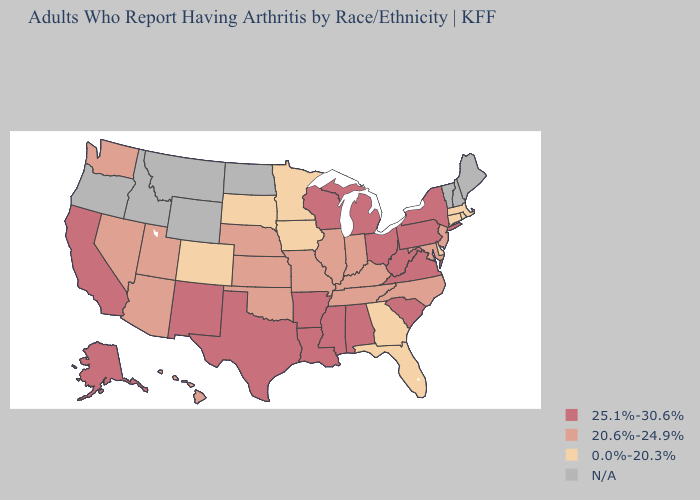Is the legend a continuous bar?
Write a very short answer. No. Does Connecticut have the highest value in the Northeast?
Keep it brief. No. Does the first symbol in the legend represent the smallest category?
Be succinct. No. What is the highest value in the South ?
Answer briefly. 25.1%-30.6%. Name the states that have a value in the range 25.1%-30.6%?
Short answer required. Alabama, Alaska, Arkansas, California, Louisiana, Michigan, Mississippi, New Mexico, New York, Ohio, Pennsylvania, South Carolina, Texas, Virginia, West Virginia, Wisconsin. What is the highest value in the USA?
Quick response, please. 25.1%-30.6%. What is the value of Michigan?
Answer briefly. 25.1%-30.6%. What is the value of Wyoming?
Write a very short answer. N/A. Among the states that border Ohio , does Michigan have the lowest value?
Quick response, please. No. Among the states that border New Jersey , which have the lowest value?
Write a very short answer. Delaware. How many symbols are there in the legend?
Give a very brief answer. 4. What is the value of Hawaii?
Keep it brief. 20.6%-24.9%. Does the map have missing data?
Quick response, please. Yes. 